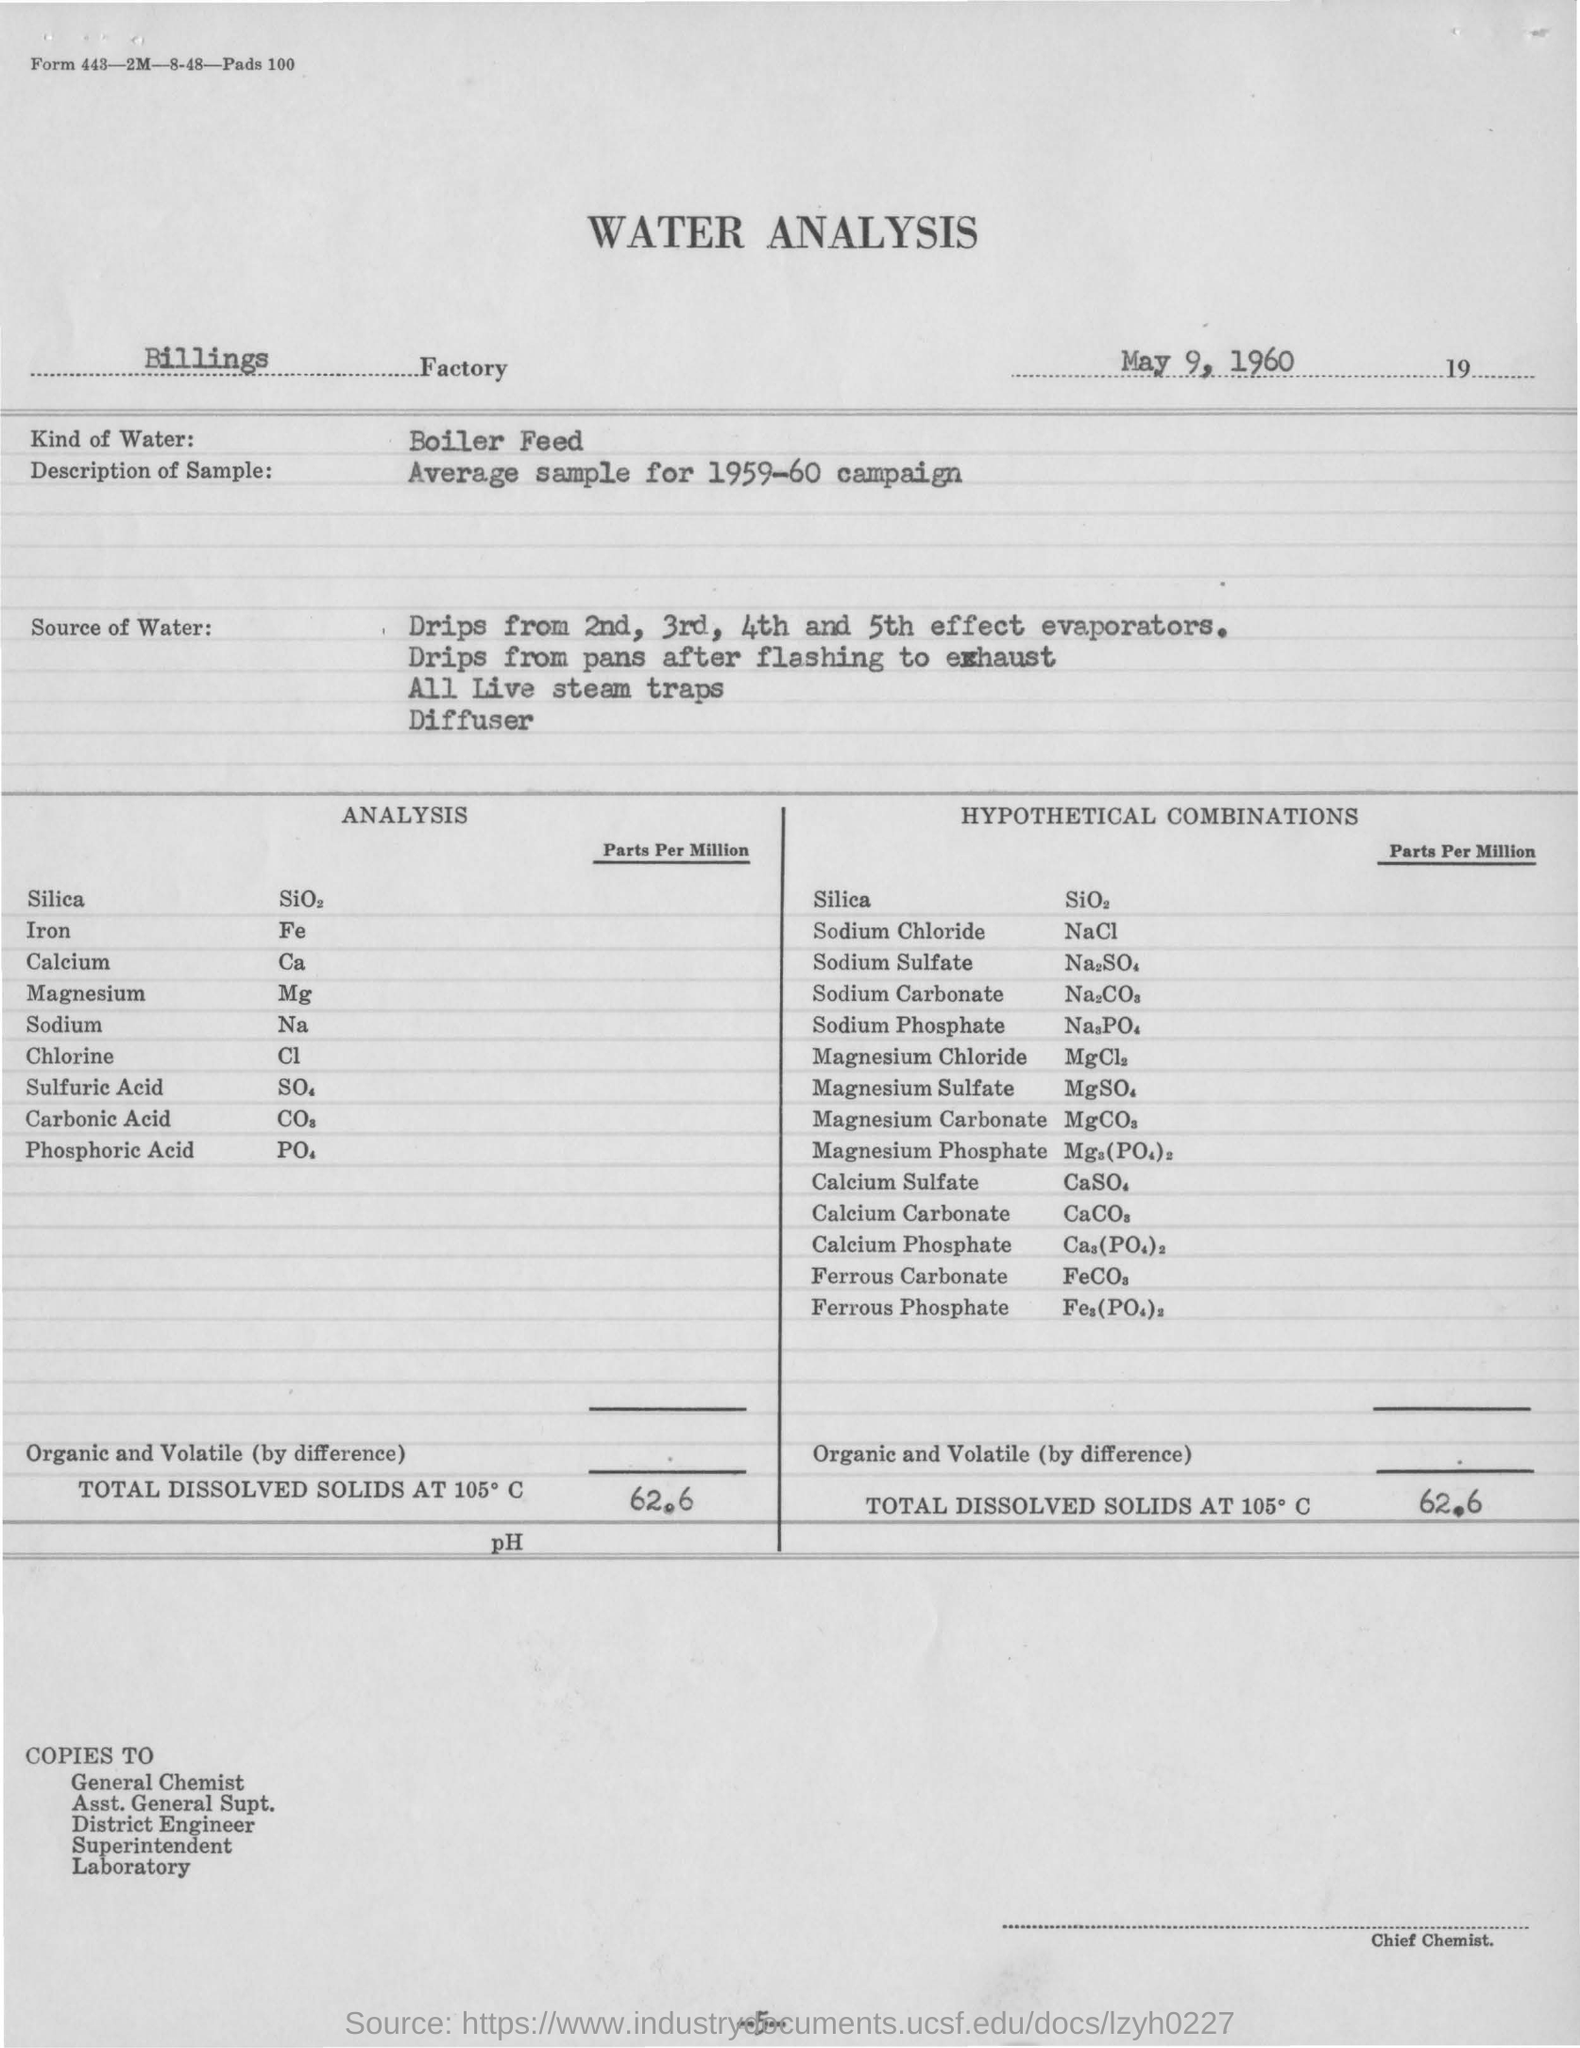What kind of water was used for the analysis?
Offer a very short reply. BOILER FEED. Which is the date mentioned in the report?
Keep it short and to the point. May 9, 1960. 